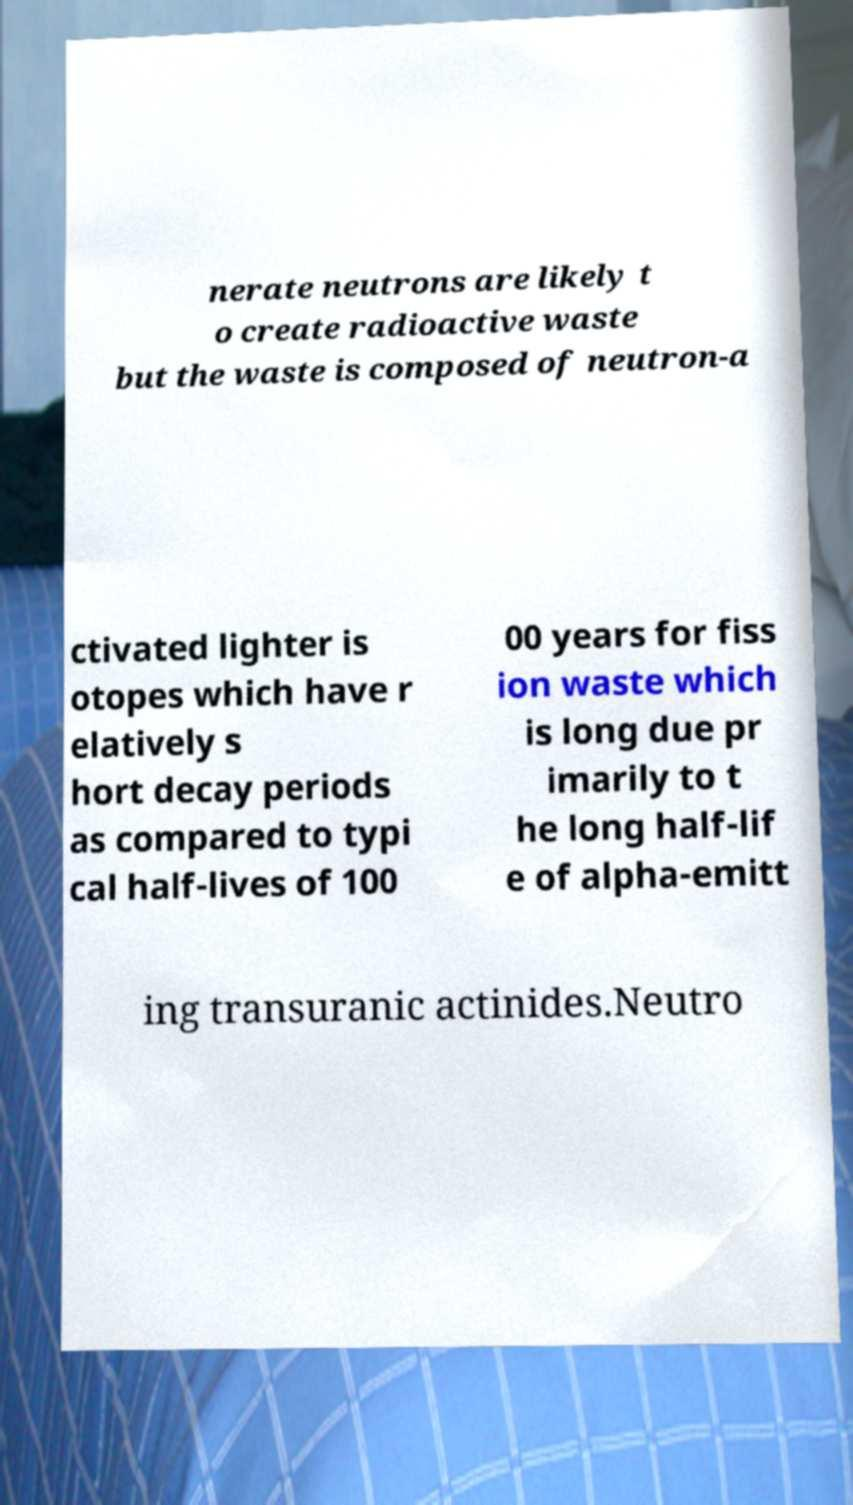I need the written content from this picture converted into text. Can you do that? nerate neutrons are likely t o create radioactive waste but the waste is composed of neutron-a ctivated lighter is otopes which have r elatively s hort decay periods as compared to typi cal half-lives of 100 00 years for fiss ion waste which is long due pr imarily to t he long half-lif e of alpha-emitt ing transuranic actinides.Neutro 